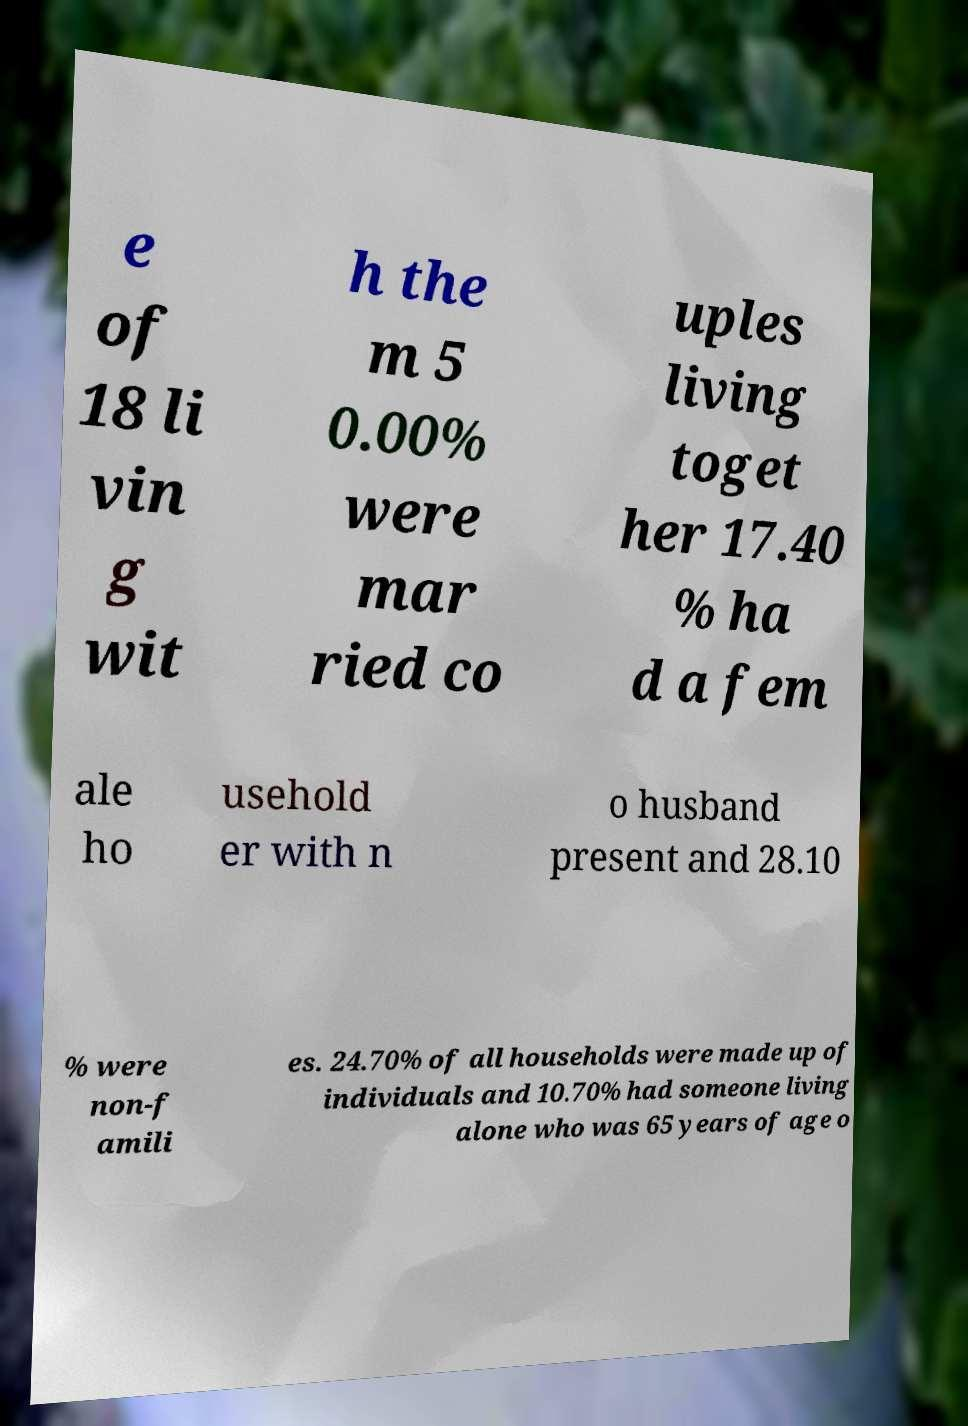Could you assist in decoding the text presented in this image and type it out clearly? e of 18 li vin g wit h the m 5 0.00% were mar ried co uples living toget her 17.40 % ha d a fem ale ho usehold er with n o husband present and 28.10 % were non-f amili es. 24.70% of all households were made up of individuals and 10.70% had someone living alone who was 65 years of age o 